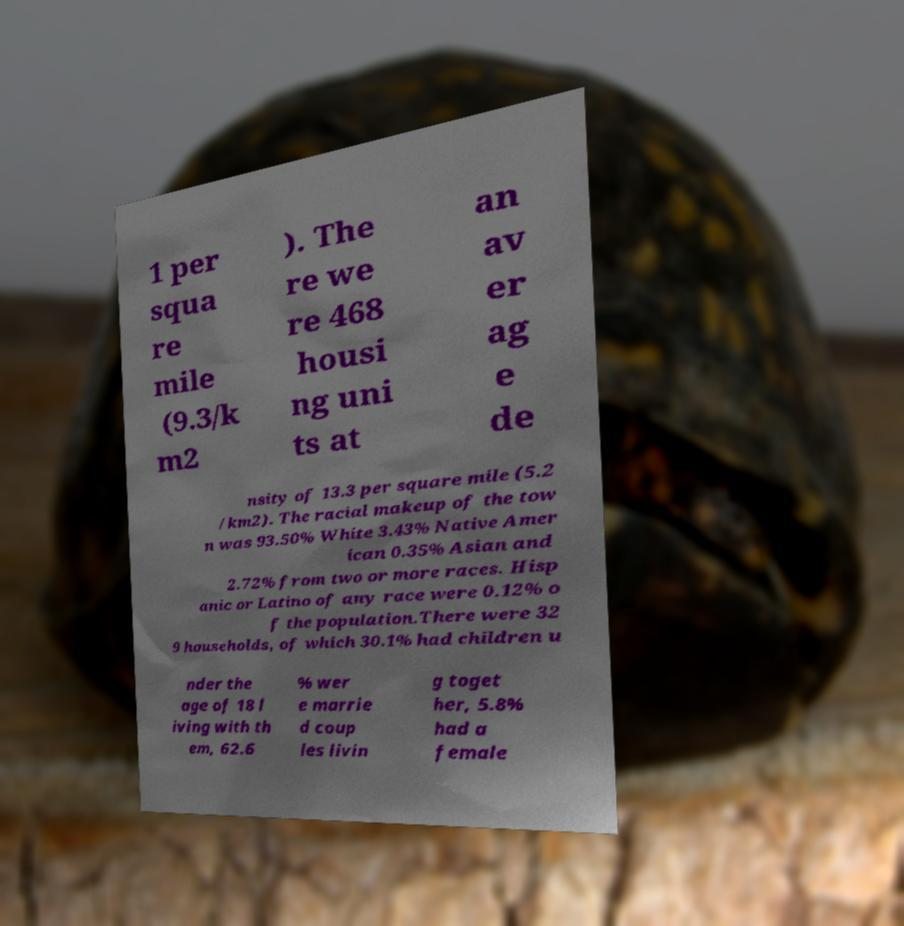Please identify and transcribe the text found in this image. 1 per squa re mile (9.3/k m2 ). The re we re 468 housi ng uni ts at an av er ag e de nsity of 13.3 per square mile (5.2 /km2). The racial makeup of the tow n was 93.50% White 3.43% Native Amer ican 0.35% Asian and 2.72% from two or more races. Hisp anic or Latino of any race were 0.12% o f the population.There were 32 9 households, of which 30.1% had children u nder the age of 18 l iving with th em, 62.6 % wer e marrie d coup les livin g toget her, 5.8% had a female 